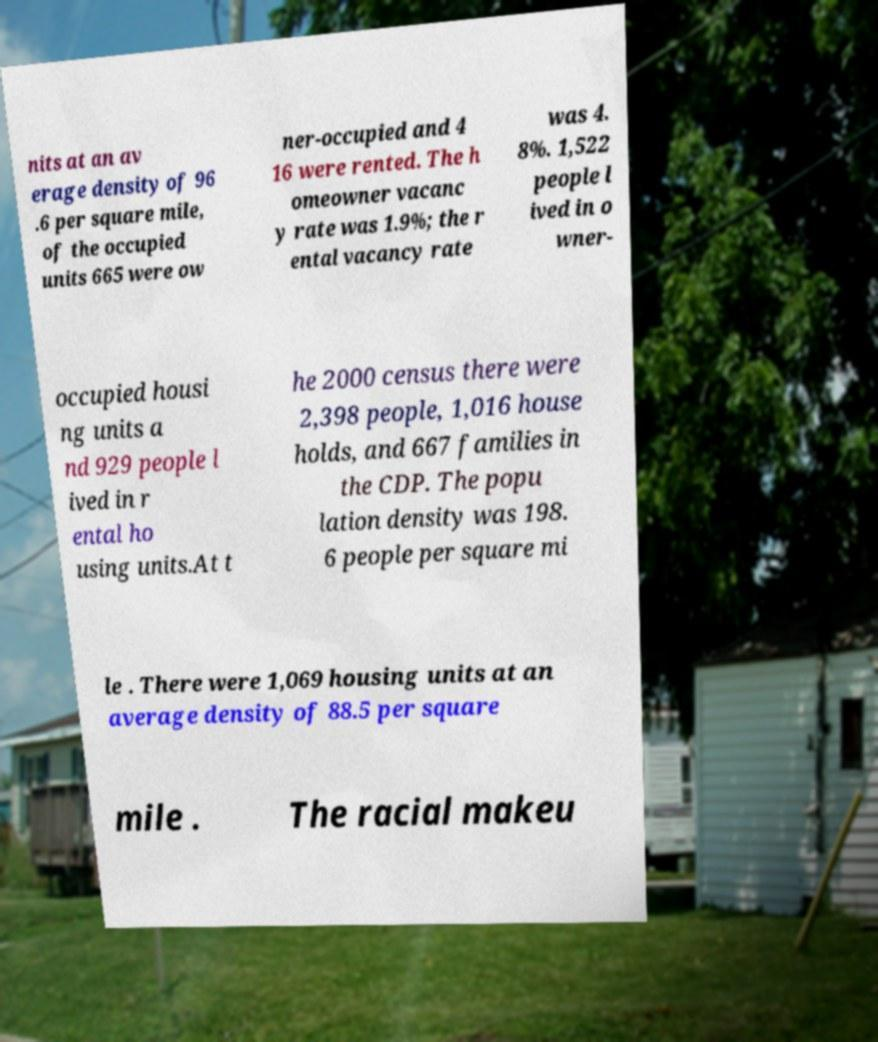Please read and relay the text visible in this image. What does it say? nits at an av erage density of 96 .6 per square mile, of the occupied units 665 were ow ner-occupied and 4 16 were rented. The h omeowner vacanc y rate was 1.9%; the r ental vacancy rate was 4. 8%. 1,522 people l ived in o wner- occupied housi ng units a nd 929 people l ived in r ental ho using units.At t he 2000 census there were 2,398 people, 1,016 house holds, and 667 families in the CDP. The popu lation density was 198. 6 people per square mi le . There were 1,069 housing units at an average density of 88.5 per square mile . The racial makeu 